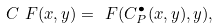Convert formula to latex. <formula><loc_0><loc_0><loc_500><loc_500>C _ { \ } F ( x , y ) = \ F ( C _ { P } ^ { \bullet } ( x , y ) , y ) ,</formula> 